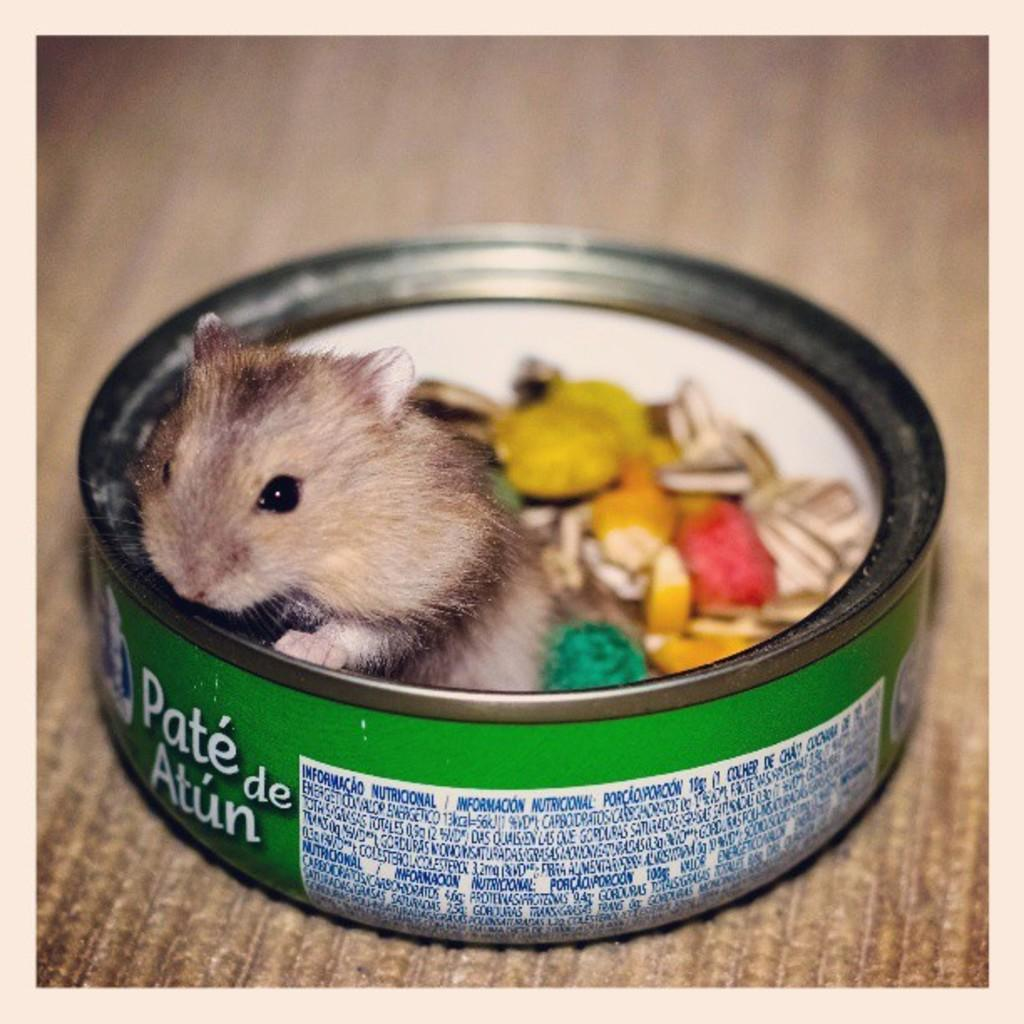What animal is present in the image? There is a mouse in the image. Where is the mouse located? The mouse is in a box. What is visible at the bottom of the image? There is a table at the bottom of the image. What type of tax is being discussed in the image? There is no discussion of tax in the image; it features a mouse in a box and a table at the bottom. 